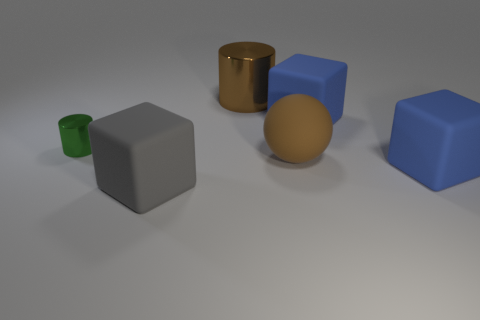Subtract all cyan balls. Subtract all red cylinders. How many balls are left? 1 Add 3 large red cylinders. How many objects exist? 9 Subtract all cylinders. How many objects are left? 4 Add 1 large gray rubber things. How many large gray rubber things exist? 2 Subtract 0 red blocks. How many objects are left? 6 Subtract all brown matte balls. Subtract all balls. How many objects are left? 4 Add 2 blue cubes. How many blue cubes are left? 4 